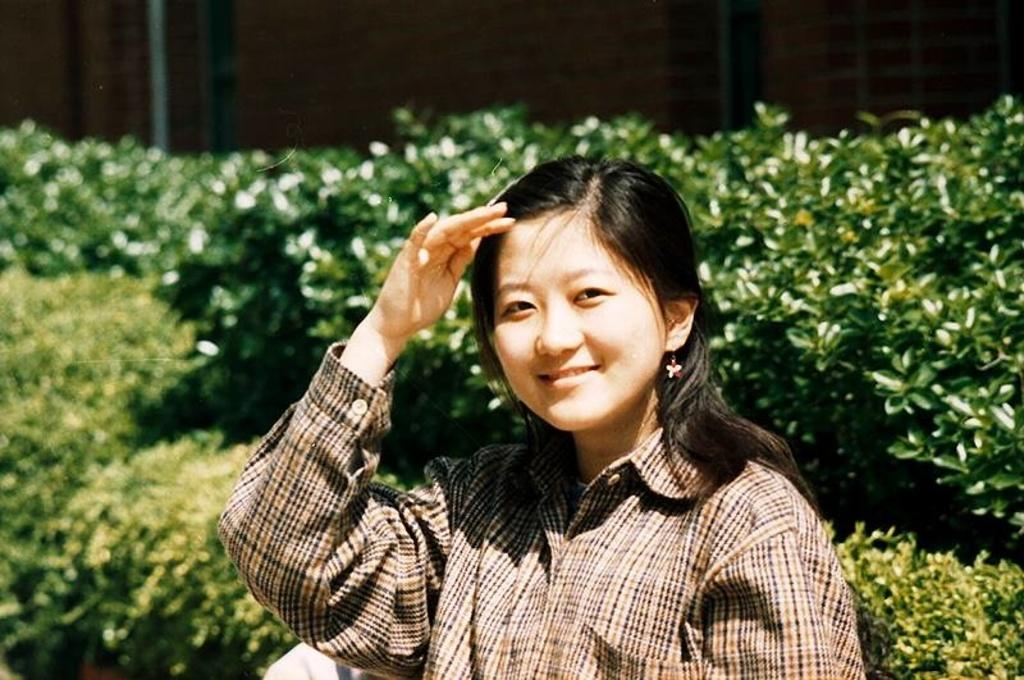Who is the main subject in the image? There is a lady in the center of the image. What is the lady doing in the image? The lady is standing and smiling. What can be seen in the background of the image? There are bushes in the background of the image. What company does the lady represent in the image? There is no information about a company or any affiliation in the image. How does the lady contribute to the conservation of the earth in the image? There is no information about the lady's actions or any environmental context in the image. 